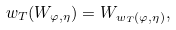<formula> <loc_0><loc_0><loc_500><loc_500>w _ { T } ( W _ { \varphi , \eta } ) = W _ { w _ { T } ( \varphi , \eta ) } ,</formula> 